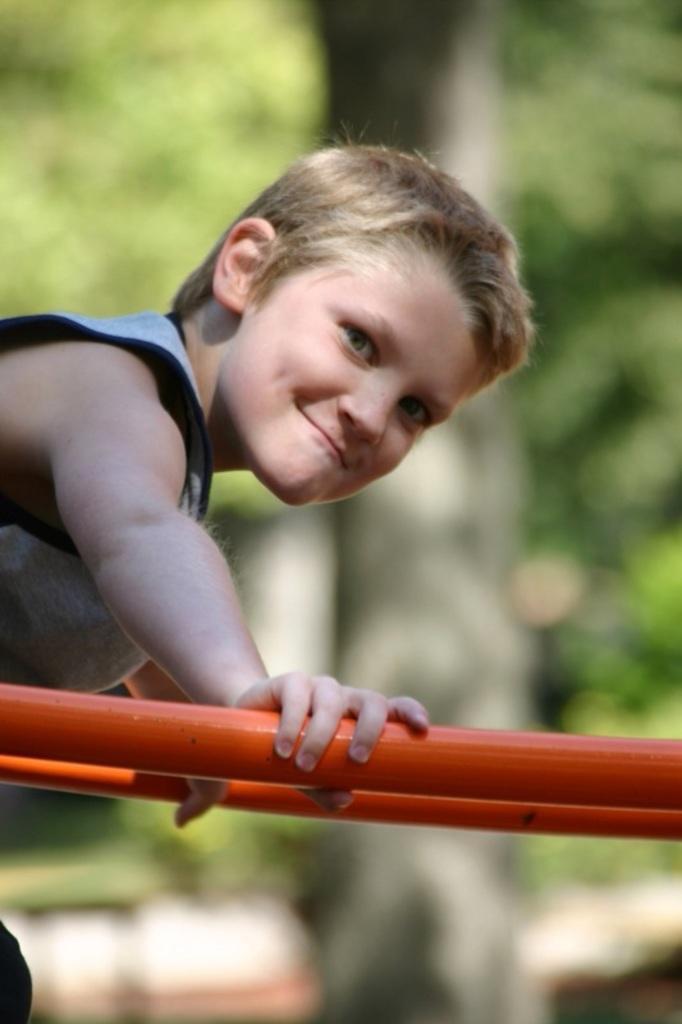Describe this image in one or two sentences. On the left side of this image there is a person holding a metal rod, smiling and giving pose for the picture. The background is blurred. 